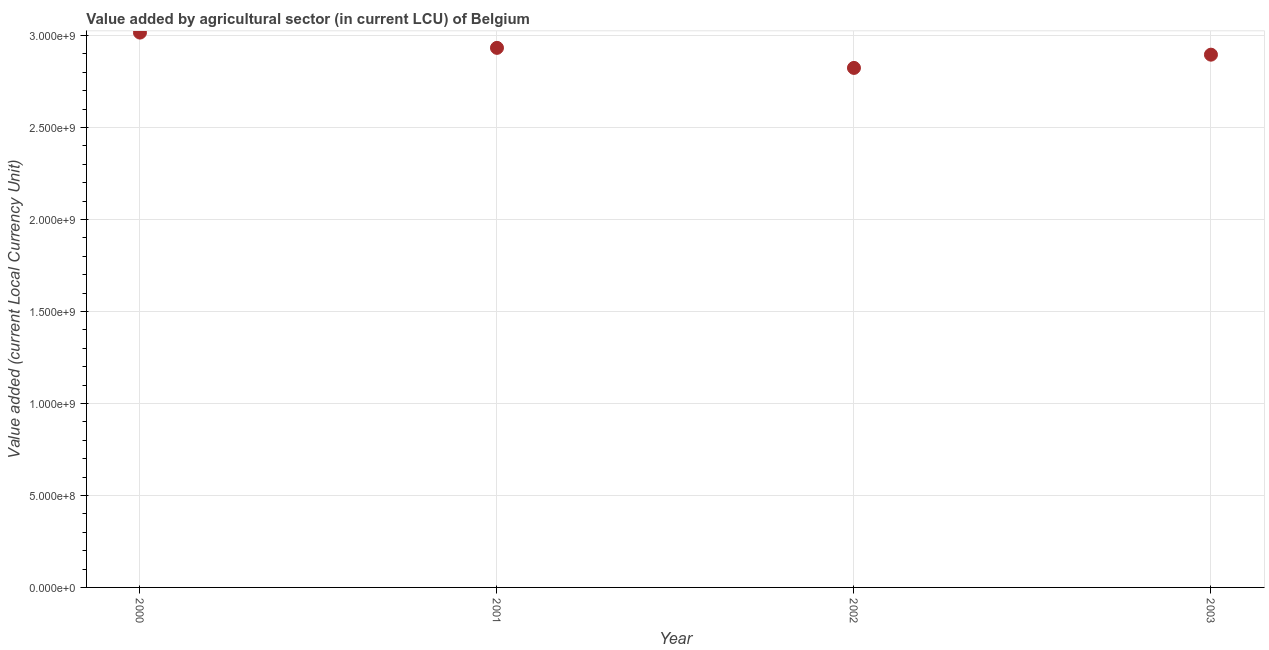What is the value added by agriculture sector in 2003?
Your answer should be compact. 2.90e+09. Across all years, what is the maximum value added by agriculture sector?
Your answer should be very brief. 3.02e+09. Across all years, what is the minimum value added by agriculture sector?
Give a very brief answer. 2.82e+09. In which year was the value added by agriculture sector maximum?
Your response must be concise. 2000. In which year was the value added by agriculture sector minimum?
Your answer should be very brief. 2002. What is the sum of the value added by agriculture sector?
Offer a very short reply. 1.17e+1. What is the difference between the value added by agriculture sector in 2001 and 2002?
Provide a succinct answer. 1.09e+08. What is the average value added by agriculture sector per year?
Offer a very short reply. 2.92e+09. What is the median value added by agriculture sector?
Ensure brevity in your answer.  2.91e+09. In how many years, is the value added by agriculture sector greater than 2900000000 LCU?
Make the answer very short. 2. What is the ratio of the value added by agriculture sector in 2000 to that in 2003?
Your answer should be very brief. 1.04. What is the difference between the highest and the second highest value added by agriculture sector?
Your answer should be very brief. 8.30e+07. What is the difference between the highest and the lowest value added by agriculture sector?
Your response must be concise. 1.92e+08. In how many years, is the value added by agriculture sector greater than the average value added by agriculture sector taken over all years?
Offer a terse response. 2. How many dotlines are there?
Offer a terse response. 1. How many years are there in the graph?
Your response must be concise. 4. Are the values on the major ticks of Y-axis written in scientific E-notation?
Your answer should be compact. Yes. Does the graph contain any zero values?
Ensure brevity in your answer.  No. What is the title of the graph?
Your response must be concise. Value added by agricultural sector (in current LCU) of Belgium. What is the label or title of the X-axis?
Your answer should be compact. Year. What is the label or title of the Y-axis?
Your answer should be compact. Value added (current Local Currency Unit). What is the Value added (current Local Currency Unit) in 2000?
Offer a terse response. 3.02e+09. What is the Value added (current Local Currency Unit) in 2001?
Give a very brief answer. 2.93e+09. What is the Value added (current Local Currency Unit) in 2002?
Ensure brevity in your answer.  2.82e+09. What is the Value added (current Local Currency Unit) in 2003?
Give a very brief answer. 2.90e+09. What is the difference between the Value added (current Local Currency Unit) in 2000 and 2001?
Ensure brevity in your answer.  8.30e+07. What is the difference between the Value added (current Local Currency Unit) in 2000 and 2002?
Keep it short and to the point. 1.92e+08. What is the difference between the Value added (current Local Currency Unit) in 2000 and 2003?
Ensure brevity in your answer.  1.20e+08. What is the difference between the Value added (current Local Currency Unit) in 2001 and 2002?
Your answer should be very brief. 1.09e+08. What is the difference between the Value added (current Local Currency Unit) in 2001 and 2003?
Provide a short and direct response. 3.70e+07. What is the difference between the Value added (current Local Currency Unit) in 2002 and 2003?
Provide a succinct answer. -7.20e+07. What is the ratio of the Value added (current Local Currency Unit) in 2000 to that in 2001?
Give a very brief answer. 1.03. What is the ratio of the Value added (current Local Currency Unit) in 2000 to that in 2002?
Provide a short and direct response. 1.07. What is the ratio of the Value added (current Local Currency Unit) in 2000 to that in 2003?
Offer a very short reply. 1.04. What is the ratio of the Value added (current Local Currency Unit) in 2001 to that in 2002?
Your answer should be very brief. 1.04. What is the ratio of the Value added (current Local Currency Unit) in 2001 to that in 2003?
Offer a very short reply. 1.01. 